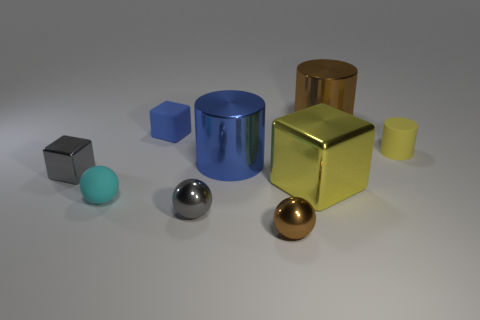Do the big metal thing behind the big blue shiny cylinder and the blue thing that is in front of the small blue object have the same shape?
Offer a very short reply. Yes. What number of objects are brown objects that are right of the small brown shiny sphere or matte spheres?
Provide a succinct answer. 2. There is a tiny object that is the same color as the small metallic cube; what is its material?
Offer a terse response. Metal. Are there any small rubber balls that are to the right of the metal ball that is in front of the shiny ball that is left of the tiny brown thing?
Provide a short and direct response. No. Is the number of tiny gray things right of the big blue metal thing less than the number of blocks that are in front of the blue rubber cube?
Make the answer very short. Yes. What is the color of the small cylinder that is made of the same material as the small blue block?
Keep it short and to the point. Yellow. The thing to the right of the brown metallic thing right of the large metal block is what color?
Your answer should be very brief. Yellow. Is there another cube of the same color as the tiny rubber block?
Keep it short and to the point. No. There is a cyan thing that is the same size as the blue cube; what shape is it?
Your response must be concise. Sphere. There is a brown shiny thing behind the tiny gray cube; what number of small gray metal things are to the right of it?
Ensure brevity in your answer.  0. 